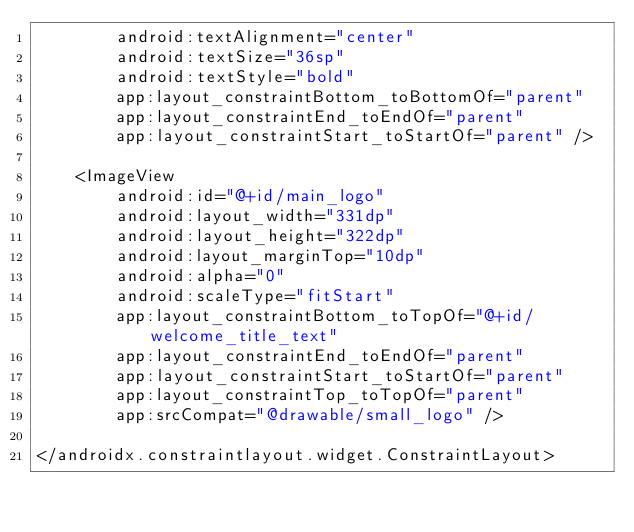<code> <loc_0><loc_0><loc_500><loc_500><_XML_>        android:textAlignment="center"
        android:textSize="36sp"
        android:textStyle="bold"
        app:layout_constraintBottom_toBottomOf="parent"
        app:layout_constraintEnd_toEndOf="parent"
        app:layout_constraintStart_toStartOf="parent" />

    <ImageView
        android:id="@+id/main_logo"
        android:layout_width="331dp"
        android:layout_height="322dp"
        android:layout_marginTop="10dp"
        android:alpha="0"
        android:scaleType="fitStart"
        app:layout_constraintBottom_toTopOf="@+id/welcome_title_text"
        app:layout_constraintEnd_toEndOf="parent"
        app:layout_constraintStart_toStartOf="parent"
        app:layout_constraintTop_toTopOf="parent"
        app:srcCompat="@drawable/small_logo" />

</androidx.constraintlayout.widget.ConstraintLayout></code> 